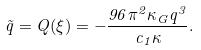Convert formula to latex. <formula><loc_0><loc_0><loc_500><loc_500>\tilde { q } = Q ( \xi ) = - \frac { 9 6 \pi ^ { 2 } \kappa _ { G } q ^ { 3 } } { c _ { 1 } \kappa } .</formula> 